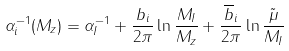<formula> <loc_0><loc_0><loc_500><loc_500>\alpha _ { i } ^ { - 1 } ( M _ { z } ) = \alpha _ { I } ^ { - 1 } + \frac { b _ { i } } { 2 \pi } \ln \frac { M _ { I } } { M _ { z } } + \frac { \overline { b } _ { i } } { 2 \pi } \ln \frac { \tilde { \mu } } { M _ { I } }</formula> 